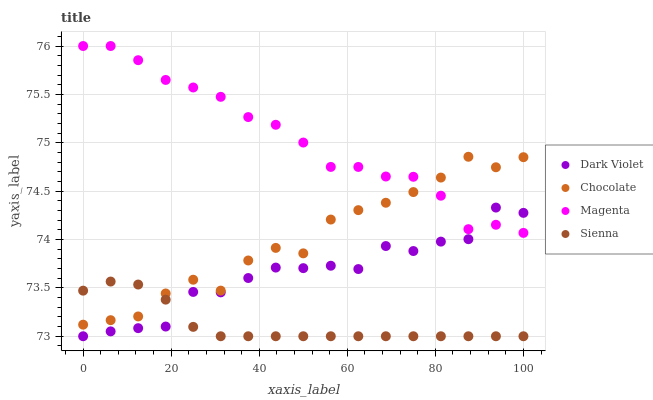Does Sienna have the minimum area under the curve?
Answer yes or no. Yes. Does Magenta have the maximum area under the curve?
Answer yes or no. Yes. Does Dark Violet have the minimum area under the curve?
Answer yes or no. No. Does Dark Violet have the maximum area under the curve?
Answer yes or no. No. Is Sienna the smoothest?
Answer yes or no. Yes. Is Chocolate the roughest?
Answer yes or no. Yes. Is Magenta the smoothest?
Answer yes or no. No. Is Magenta the roughest?
Answer yes or no. No. Does Sienna have the lowest value?
Answer yes or no. Yes. Does Magenta have the lowest value?
Answer yes or no. No. Does Magenta have the highest value?
Answer yes or no. Yes. Does Dark Violet have the highest value?
Answer yes or no. No. Is Sienna less than Magenta?
Answer yes or no. Yes. Is Magenta greater than Sienna?
Answer yes or no. Yes. Does Sienna intersect Dark Violet?
Answer yes or no. Yes. Is Sienna less than Dark Violet?
Answer yes or no. No. Is Sienna greater than Dark Violet?
Answer yes or no. No. Does Sienna intersect Magenta?
Answer yes or no. No. 